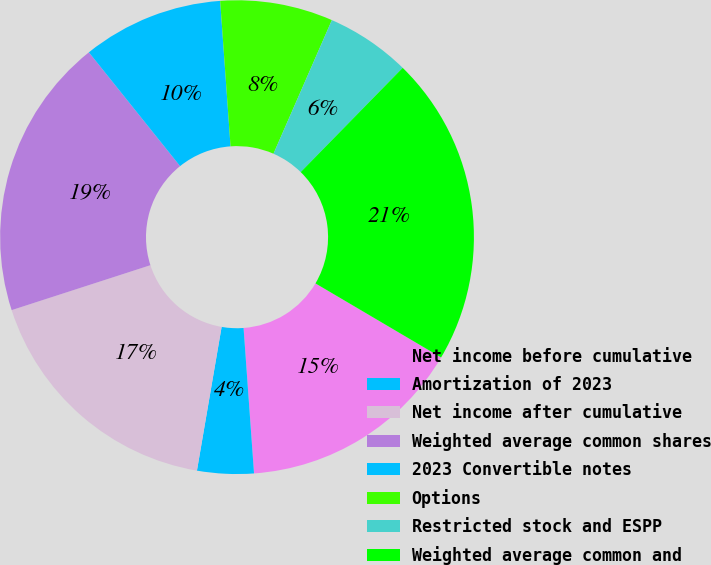Convert chart to OTSL. <chart><loc_0><loc_0><loc_500><loc_500><pie_chart><fcel>Net income before cumulative<fcel>Amortization of 2023<fcel>Net income after cumulative<fcel>Weighted average common shares<fcel>2023 Convertible notes<fcel>Options<fcel>Restricted stock and ESPP<fcel>Weighted average common and<nl><fcel>15.38%<fcel>3.85%<fcel>17.31%<fcel>19.23%<fcel>9.62%<fcel>7.69%<fcel>5.77%<fcel>21.15%<nl></chart> 